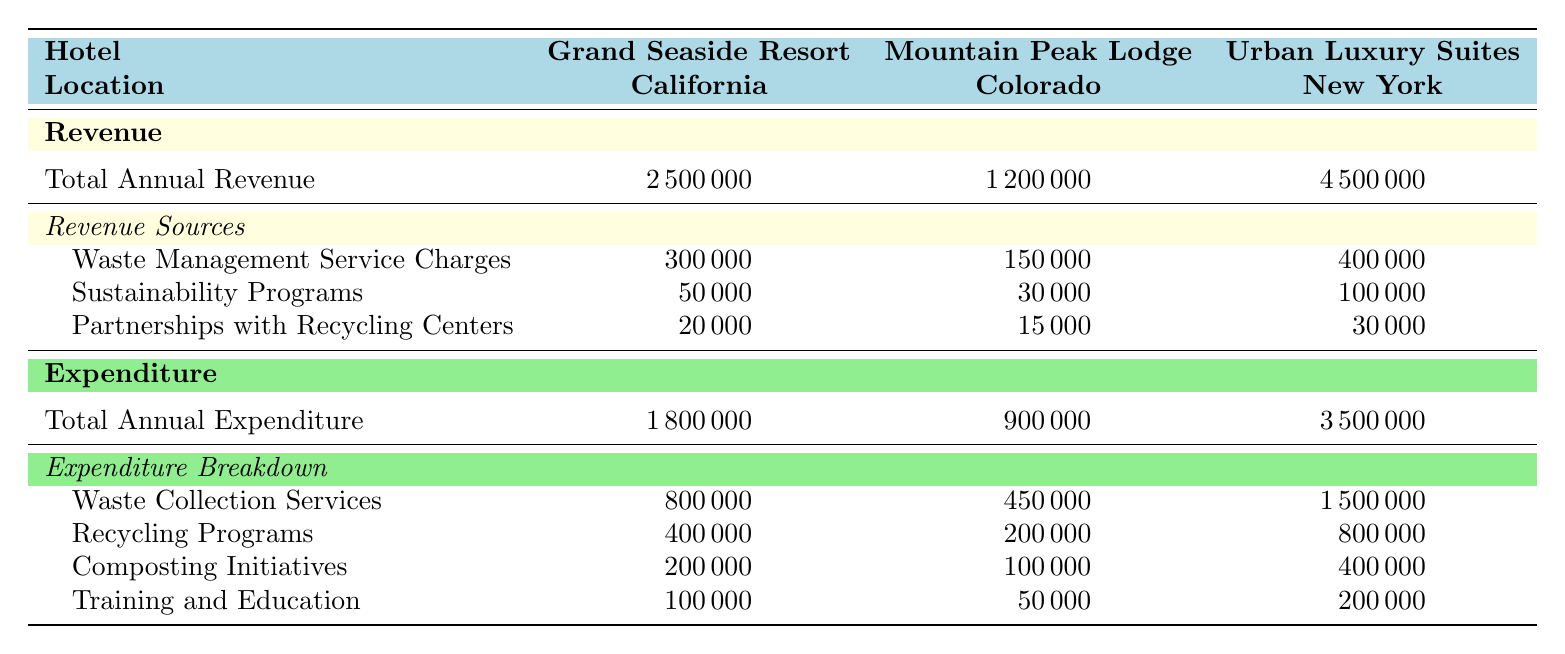What is the total annual revenue for the Grand Seaside Resort? The table shows a specific revenue section for Grand Seaside Resort, listing the total annual revenue value directly. From the table, Grand Seaside Resort’s total annual revenue is listed as 2,500,000.
Answer: 2,500,000 What was the total annual expenditure for Mountain Peak Lodge? The table provides a direct value under the expenditure section for Mountain Peak Lodge. According to the expenditure row, the total annual expenditure for Mountain Peak Lodge is 900,000.
Answer: 900,000 What is the total revenue from waste management service charges for all hotels combined? To calculate the total revenue from waste management service charges, we look at the values for each hotel: Grand Seaside Resort (300,000), Mountain Peak Lodge (150,000), and Urban Luxury Suites (400,000). Adding these values gives: 300,000 + 150,000 + 400,000 = 850,000.
Answer: 850,000 Did Urban Luxury Suites have a higher total expenditure than Grand Seaside Resort? By checking the total annual expenditures listed in the table, Urban Luxury Suites has a total expenditure of 3,500,000, while Grand Seaside Resort has 1,800,000. Since 3,500,000 is greater than 1,800,000, the statement is true.
Answer: Yes What percentage of the total annual revenue for the Grand Seaside Resort is represented by sustainability programs? To find the percentage of total annual revenue represented by sustainability programs, we take the revenue from sustainability programs (50,000) and divide it by the total annual revenue (2,500,000), then multiply by 100: (50,000 / 2,500,000) * 100 = 2%.
Answer: 2% What is the total expenditure on recycling programs across all hotels? We sum the expenditure on recycling programs for each hotel: Grand Seaside Resort (400,000), Mountain Peak Lodge (200,000), and Urban Luxury Suites (800,000). The total is 400,000 + 200,000 + 800,000 = 1,400,000.
Answer: 1,400,000 Is the expenditure on composting initiatives at the Urban Luxury Suites equal to the combined expenditures for composting initiatives at the other two hotels? The composting expenditures are: Urban Luxury Suites (400,000), Grand Seaside Resort (200,000), Mountain Peak Lodge (100,000). Adding the amounts for the other two hotels gives: 200,000 + 100,000 = 300,000. Since 400,000 is not equal to 300,000, the statement is false.
Answer: No Which hotel has the highest total annual revenue and what is that amount? By comparing the total annual revenue values: Grand Seaside Resort (2,500,000), Mountain Peak Lodge (1,200,000), Urban Luxury Suites (4,500,000), we can see that Urban Luxury Suites has the highest value at 4,500,000.
Answer: Urban Luxury Suites, 4,500,000 What is the difference in total annual expenditure between the Grand Seaside Resort and Mountain Peak Lodge? The total annual expenditure for Grand Seaside Resort is 1,800,000 and for Mountain Peak Lodge it is 900,000. To find the difference, we subtract: 1,800,000 - 900,000 = 900,000.
Answer: 900,000 